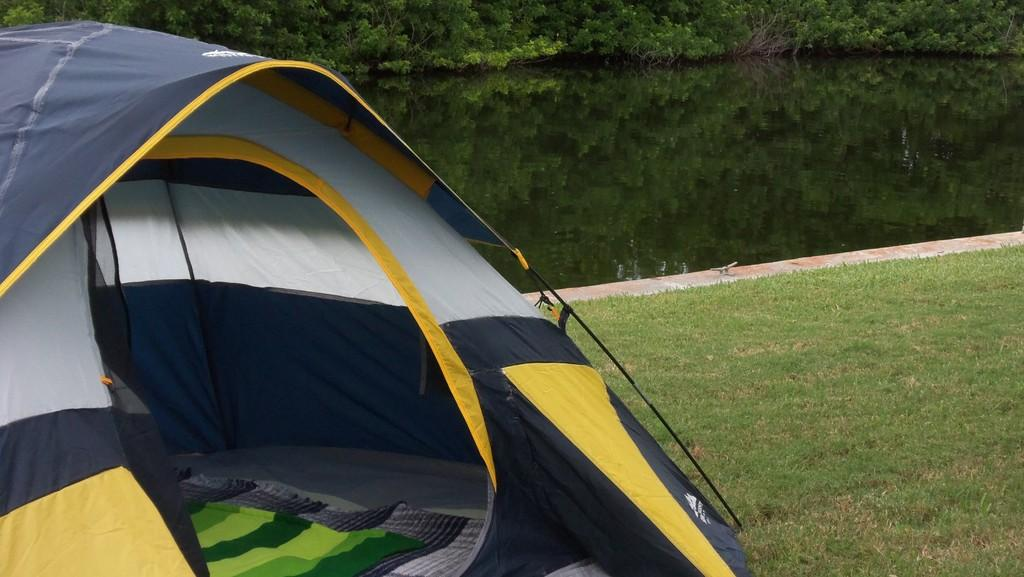What type of ground is visible in the image? There is grass ground in the image. What structure is located on the grass ground? There is a tent house on the grass ground. What can be seen inside the tent house? There are clothes visible inside the tent house. What is visible in the background of the image? There is water and trees visible in the background of the image. Can you see any wings on the grass ground in the image? There are no wings visible on the grass ground in the image. What type of toothpaste is being used to clean the clothes inside the tent house? There is no toothpaste present in the image, and the clothes inside the tent house are not being cleaned. 